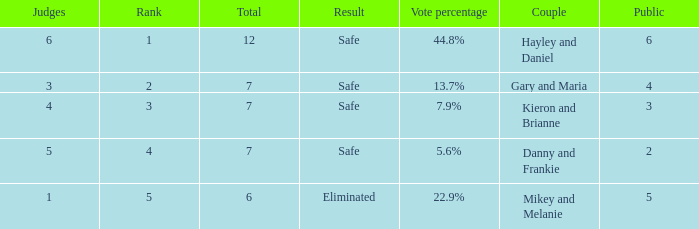Write the full table. {'header': ['Judges', 'Rank', 'Total', 'Result', 'Vote percentage', 'Couple', 'Public'], 'rows': [['6', '1', '12', 'Safe', '44.8%', 'Hayley and Daniel', '6'], ['3', '2', '7', 'Safe', '13.7%', 'Gary and Maria', '4'], ['4', '3', '7', 'Safe', '7.9%', 'Kieron and Brianne', '3'], ['5', '4', '7', 'Safe', '5.6%', 'Danny and Frankie', '2'], ['1', '5', '6', 'Eliminated', '22.9%', 'Mikey and Melanie', '5']]} How many public is there for the couple that got eliminated? 5.0. 